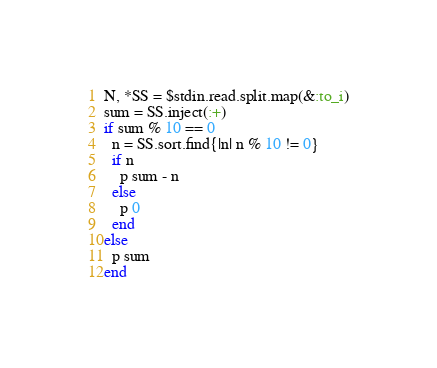Convert code to text. <code><loc_0><loc_0><loc_500><loc_500><_Ruby_>N, *SS = $stdin.read.split.map(&:to_i)
sum = SS.inject(:+)
if sum % 10 == 0
  n = SS.sort.find{|n| n % 10 != 0}
  if n 
    p sum - n
  else
    p 0
  end
else
  p sum
end
</code> 